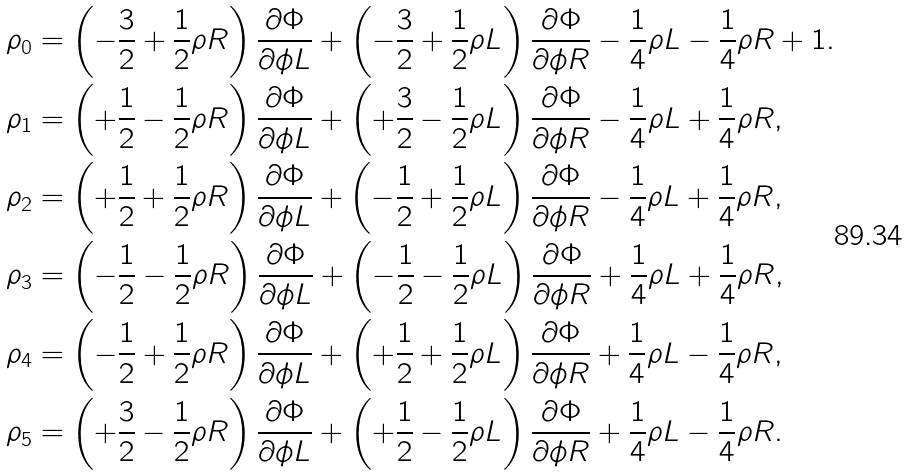<formula> <loc_0><loc_0><loc_500><loc_500>\rho _ { 0 } & = \left ( - \frac { 3 } { 2 } + \frac { 1 } { 2 } \rho R \right ) \frac { \partial \Phi } { \partial \phi L } + \left ( - \frac { 3 } { 2 } + \frac { 1 } { 2 } \rho L \right ) \frac { \partial \Phi } { \partial \phi R } - \frac { 1 } { 4 } \rho L - \frac { 1 } { 4 } \rho R + 1 . \\ \rho _ { 1 } & = \left ( + \frac { 1 } { 2 } - \frac { 1 } { 2 } \rho R \right ) \frac { \partial \Phi } { \partial \phi L } + \left ( + \frac { 3 } { 2 } - \frac { 1 } { 2 } \rho L \right ) \frac { \partial \Phi } { \partial \phi R } - \frac { 1 } { 4 } \rho L + \frac { 1 } { 4 } \rho R , \\ \rho _ { 2 } & = \left ( + \frac { 1 } { 2 } + \frac { 1 } { 2 } \rho R \right ) \frac { \partial \Phi } { \partial \phi L } + \left ( - \frac { 1 } { 2 } + \frac { 1 } { 2 } \rho L \right ) \frac { \partial \Phi } { \partial \phi R } - \frac { 1 } { 4 } \rho L + \frac { 1 } { 4 } \rho R , \\ \rho _ { 3 } & = \left ( - \frac { 1 } { 2 } - \frac { 1 } { 2 } \rho R \right ) \frac { \partial \Phi } { \partial \phi L } + \left ( - \frac { 1 } { 2 } - \frac { 1 } { 2 } \rho L \right ) \frac { \partial \Phi } { \partial \phi R } + \frac { 1 } { 4 } \rho L + \frac { 1 } { 4 } \rho R , \\ \rho _ { 4 } & = \left ( - \frac { 1 } { 2 } + \frac { 1 } { 2 } \rho R \right ) \frac { \partial \Phi } { \partial \phi L } + \left ( + \frac { 1 } { 2 } + \frac { 1 } { 2 } \rho L \right ) \frac { \partial \Phi } { \partial \phi R } + \frac { 1 } { 4 } \rho L - \frac { 1 } { 4 } \rho R , \\ \rho _ { 5 } & = \left ( + \frac { 3 } { 2 } - \frac { 1 } { 2 } \rho R \right ) \frac { \partial \Phi } { \partial \phi L } + \left ( + \frac { 1 } { 2 } - \frac { 1 } { 2 } \rho L \right ) \frac { \partial \Phi } { \partial \phi R } + \frac { 1 } { 4 } \rho L - \frac { 1 } { 4 } \rho R .</formula> 